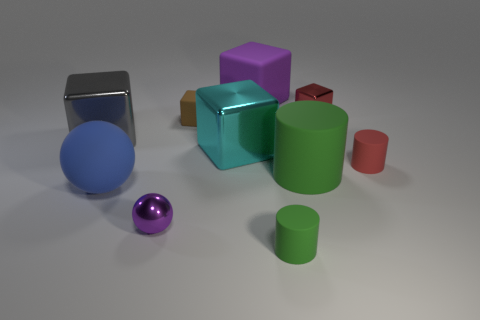Subtract all gray cubes. How many cubes are left? 4 Subtract all red balls. How many green cylinders are left? 2 Subtract all purple cubes. How many cubes are left? 4 Subtract all spheres. How many objects are left? 8 Subtract 1 spheres. How many spheres are left? 1 Subtract 0 gray cylinders. How many objects are left? 10 Subtract all brown cylinders. Subtract all blue spheres. How many cylinders are left? 3 Subtract all red rubber cylinders. Subtract all red cubes. How many objects are left? 8 Add 6 red cylinders. How many red cylinders are left? 7 Add 5 large cyan objects. How many large cyan objects exist? 6 